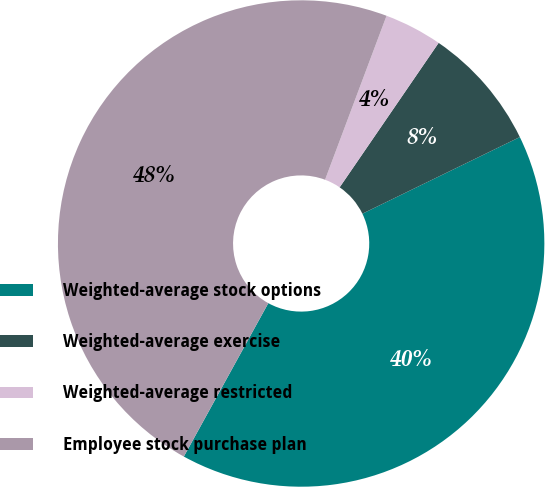Convert chart. <chart><loc_0><loc_0><loc_500><loc_500><pie_chart><fcel>Weighted-average stock options<fcel>Weighted-average exercise<fcel>Weighted-average restricted<fcel>Employee stock purchase plan<nl><fcel>40.22%<fcel>8.23%<fcel>3.85%<fcel>47.7%<nl></chart> 